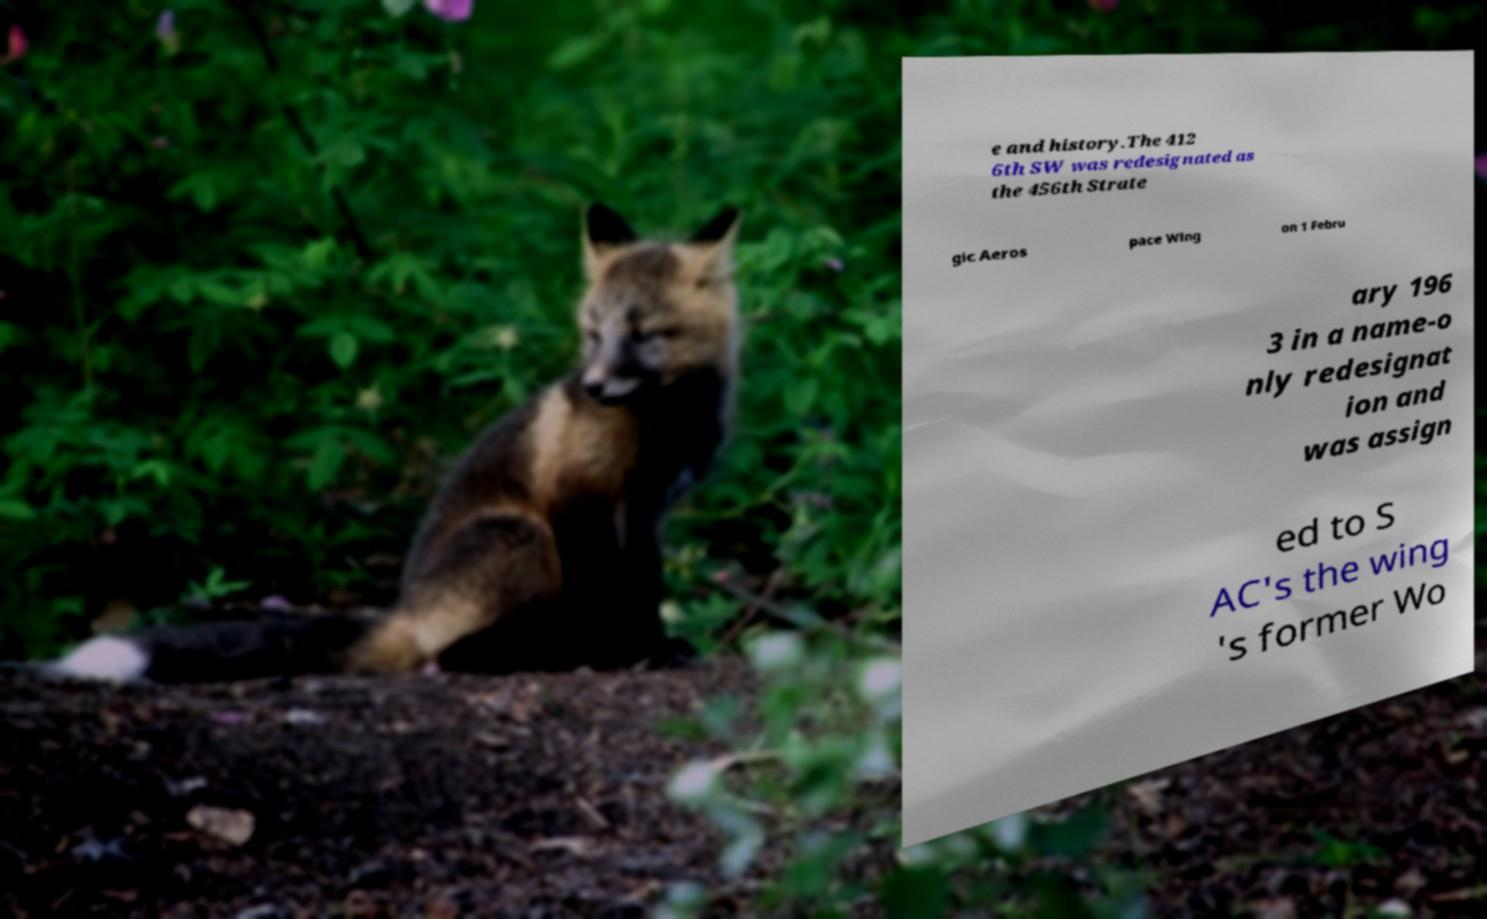Can you accurately transcribe the text from the provided image for me? e and history.The 412 6th SW was redesignated as the 456th Strate gic Aeros pace Wing on 1 Febru ary 196 3 in a name-o nly redesignat ion and was assign ed to S AC's the wing 's former Wo 